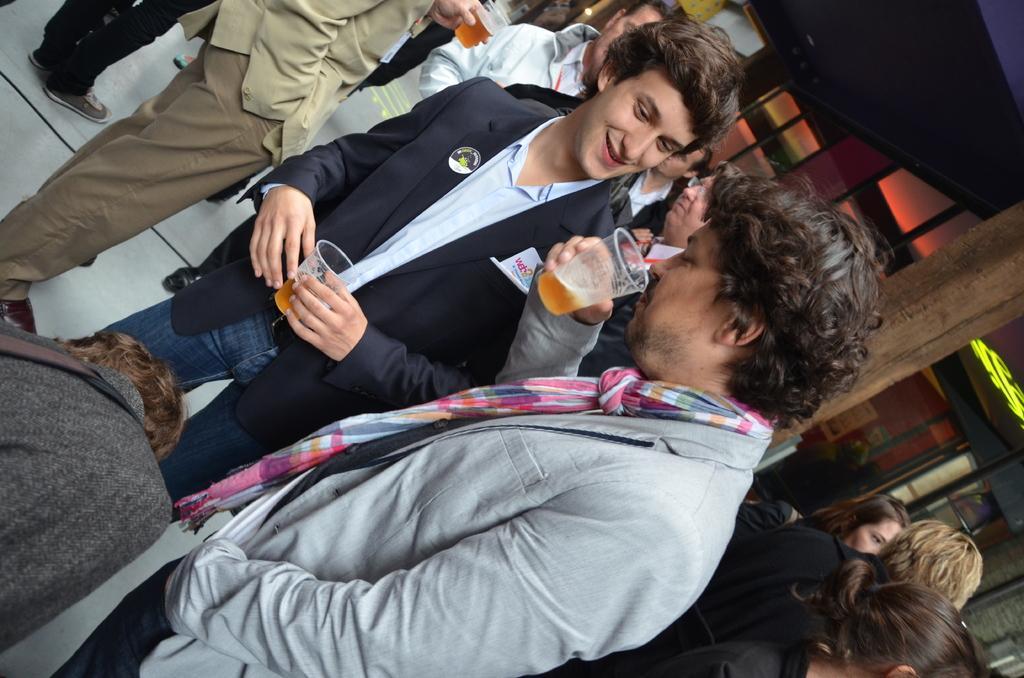How would you summarize this image in a sentence or two? It is a tilted image, in this image there are group of people inside a hall and they are drinking. 